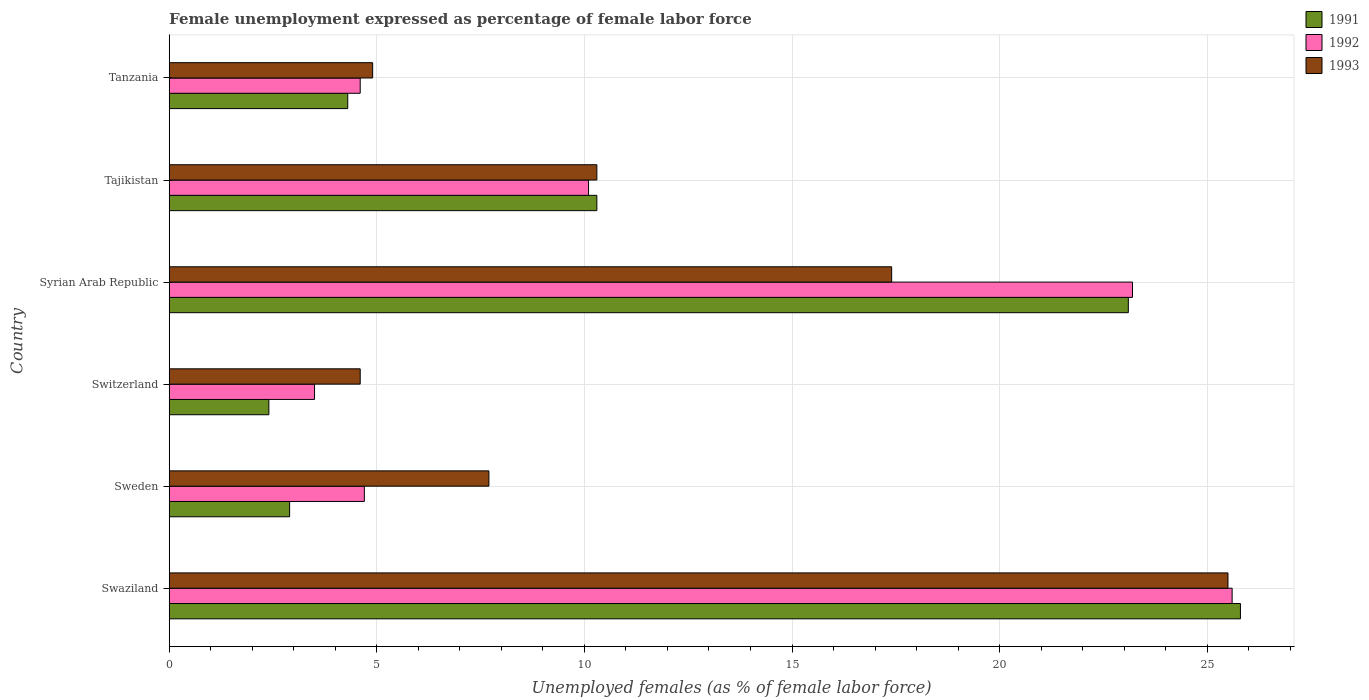Are the number of bars per tick equal to the number of legend labels?
Ensure brevity in your answer.  Yes. Are the number of bars on each tick of the Y-axis equal?
Your answer should be very brief. Yes. How many bars are there on the 6th tick from the bottom?
Keep it short and to the point. 3. What is the label of the 2nd group of bars from the top?
Provide a short and direct response. Tajikistan. In how many cases, is the number of bars for a given country not equal to the number of legend labels?
Give a very brief answer. 0. What is the unemployment in females in in 1991 in Tajikistan?
Offer a terse response. 10.3. In which country was the unemployment in females in in 1991 maximum?
Offer a very short reply. Swaziland. In which country was the unemployment in females in in 1993 minimum?
Offer a very short reply. Switzerland. What is the total unemployment in females in in 1993 in the graph?
Ensure brevity in your answer.  70.4. What is the difference between the unemployment in females in in 1993 in Syrian Arab Republic and that in Tajikistan?
Offer a terse response. 7.1. What is the difference between the unemployment in females in in 1992 in Syrian Arab Republic and the unemployment in females in in 1993 in Sweden?
Offer a terse response. 15.5. What is the average unemployment in females in in 1993 per country?
Your answer should be compact. 11.73. What is the difference between the unemployment in females in in 1991 and unemployment in females in in 1992 in Switzerland?
Ensure brevity in your answer.  -1.1. In how many countries, is the unemployment in females in in 1992 greater than 26 %?
Ensure brevity in your answer.  0. What is the ratio of the unemployment in females in in 1992 in Syrian Arab Republic to that in Tanzania?
Ensure brevity in your answer.  5.04. Is the difference between the unemployment in females in in 1991 in Swaziland and Tajikistan greater than the difference between the unemployment in females in in 1992 in Swaziland and Tajikistan?
Offer a terse response. No. What is the difference between the highest and the second highest unemployment in females in in 1992?
Your answer should be compact. 2.4. What is the difference between the highest and the lowest unemployment in females in in 1991?
Your answer should be compact. 23.4. Is the sum of the unemployment in females in in 1992 in Sweden and Syrian Arab Republic greater than the maximum unemployment in females in in 1991 across all countries?
Make the answer very short. Yes. What does the 1st bar from the bottom in Swaziland represents?
Your response must be concise. 1991. How many bars are there?
Make the answer very short. 18. Are all the bars in the graph horizontal?
Provide a succinct answer. Yes. How many countries are there in the graph?
Ensure brevity in your answer.  6. Are the values on the major ticks of X-axis written in scientific E-notation?
Your answer should be very brief. No. Does the graph contain grids?
Offer a very short reply. Yes. How many legend labels are there?
Provide a succinct answer. 3. What is the title of the graph?
Your answer should be compact. Female unemployment expressed as percentage of female labor force. What is the label or title of the X-axis?
Your answer should be very brief. Unemployed females (as % of female labor force). What is the label or title of the Y-axis?
Offer a terse response. Country. What is the Unemployed females (as % of female labor force) of 1991 in Swaziland?
Give a very brief answer. 25.8. What is the Unemployed females (as % of female labor force) of 1992 in Swaziland?
Ensure brevity in your answer.  25.6. What is the Unemployed females (as % of female labor force) of 1991 in Sweden?
Offer a very short reply. 2.9. What is the Unemployed females (as % of female labor force) in 1992 in Sweden?
Give a very brief answer. 4.7. What is the Unemployed females (as % of female labor force) of 1993 in Sweden?
Give a very brief answer. 7.7. What is the Unemployed females (as % of female labor force) in 1991 in Switzerland?
Make the answer very short. 2.4. What is the Unemployed females (as % of female labor force) of 1992 in Switzerland?
Make the answer very short. 3.5. What is the Unemployed females (as % of female labor force) of 1993 in Switzerland?
Your response must be concise. 4.6. What is the Unemployed females (as % of female labor force) of 1991 in Syrian Arab Republic?
Make the answer very short. 23.1. What is the Unemployed females (as % of female labor force) in 1992 in Syrian Arab Republic?
Give a very brief answer. 23.2. What is the Unemployed females (as % of female labor force) of 1993 in Syrian Arab Republic?
Provide a short and direct response. 17.4. What is the Unemployed females (as % of female labor force) in 1991 in Tajikistan?
Provide a succinct answer. 10.3. What is the Unemployed females (as % of female labor force) of 1992 in Tajikistan?
Your answer should be compact. 10.1. What is the Unemployed females (as % of female labor force) of 1993 in Tajikistan?
Your answer should be compact. 10.3. What is the Unemployed females (as % of female labor force) in 1991 in Tanzania?
Make the answer very short. 4.3. What is the Unemployed females (as % of female labor force) in 1992 in Tanzania?
Your response must be concise. 4.6. What is the Unemployed females (as % of female labor force) of 1993 in Tanzania?
Your answer should be very brief. 4.9. Across all countries, what is the maximum Unemployed females (as % of female labor force) of 1991?
Your answer should be very brief. 25.8. Across all countries, what is the maximum Unemployed females (as % of female labor force) in 1992?
Provide a short and direct response. 25.6. Across all countries, what is the minimum Unemployed females (as % of female labor force) in 1991?
Your response must be concise. 2.4. Across all countries, what is the minimum Unemployed females (as % of female labor force) of 1992?
Your answer should be compact. 3.5. Across all countries, what is the minimum Unemployed females (as % of female labor force) of 1993?
Ensure brevity in your answer.  4.6. What is the total Unemployed females (as % of female labor force) of 1991 in the graph?
Your answer should be very brief. 68.8. What is the total Unemployed females (as % of female labor force) in 1992 in the graph?
Your answer should be compact. 71.7. What is the total Unemployed females (as % of female labor force) of 1993 in the graph?
Offer a very short reply. 70.4. What is the difference between the Unemployed females (as % of female labor force) in 1991 in Swaziland and that in Sweden?
Your answer should be very brief. 22.9. What is the difference between the Unemployed females (as % of female labor force) of 1992 in Swaziland and that in Sweden?
Make the answer very short. 20.9. What is the difference between the Unemployed females (as % of female labor force) in 1993 in Swaziland and that in Sweden?
Ensure brevity in your answer.  17.8. What is the difference between the Unemployed females (as % of female labor force) of 1991 in Swaziland and that in Switzerland?
Provide a succinct answer. 23.4. What is the difference between the Unemployed females (as % of female labor force) of 1992 in Swaziland and that in Switzerland?
Give a very brief answer. 22.1. What is the difference between the Unemployed females (as % of female labor force) of 1993 in Swaziland and that in Switzerland?
Make the answer very short. 20.9. What is the difference between the Unemployed females (as % of female labor force) of 1992 in Swaziland and that in Syrian Arab Republic?
Your answer should be compact. 2.4. What is the difference between the Unemployed females (as % of female labor force) in 1993 in Swaziland and that in Syrian Arab Republic?
Ensure brevity in your answer.  8.1. What is the difference between the Unemployed females (as % of female labor force) in 1991 in Swaziland and that in Tajikistan?
Provide a short and direct response. 15.5. What is the difference between the Unemployed females (as % of female labor force) in 1992 in Swaziland and that in Tajikistan?
Provide a succinct answer. 15.5. What is the difference between the Unemployed females (as % of female labor force) in 1991 in Swaziland and that in Tanzania?
Your answer should be compact. 21.5. What is the difference between the Unemployed females (as % of female labor force) in 1993 in Swaziland and that in Tanzania?
Offer a very short reply. 20.6. What is the difference between the Unemployed females (as % of female labor force) in 1993 in Sweden and that in Switzerland?
Offer a very short reply. 3.1. What is the difference between the Unemployed females (as % of female labor force) in 1991 in Sweden and that in Syrian Arab Republic?
Ensure brevity in your answer.  -20.2. What is the difference between the Unemployed females (as % of female labor force) of 1992 in Sweden and that in Syrian Arab Republic?
Your response must be concise. -18.5. What is the difference between the Unemployed females (as % of female labor force) of 1993 in Sweden and that in Syrian Arab Republic?
Your answer should be compact. -9.7. What is the difference between the Unemployed females (as % of female labor force) of 1993 in Sweden and that in Tajikistan?
Provide a succinct answer. -2.6. What is the difference between the Unemployed females (as % of female labor force) of 1991 in Sweden and that in Tanzania?
Ensure brevity in your answer.  -1.4. What is the difference between the Unemployed females (as % of female labor force) in 1993 in Sweden and that in Tanzania?
Keep it short and to the point. 2.8. What is the difference between the Unemployed females (as % of female labor force) in 1991 in Switzerland and that in Syrian Arab Republic?
Your response must be concise. -20.7. What is the difference between the Unemployed females (as % of female labor force) in 1992 in Switzerland and that in Syrian Arab Republic?
Offer a terse response. -19.7. What is the difference between the Unemployed females (as % of female labor force) of 1992 in Switzerland and that in Tajikistan?
Your response must be concise. -6.6. What is the difference between the Unemployed females (as % of female labor force) of 1992 in Switzerland and that in Tanzania?
Provide a succinct answer. -1.1. What is the difference between the Unemployed females (as % of female labor force) in 1993 in Switzerland and that in Tanzania?
Provide a succinct answer. -0.3. What is the difference between the Unemployed females (as % of female labor force) of 1991 in Syrian Arab Republic and that in Tajikistan?
Ensure brevity in your answer.  12.8. What is the difference between the Unemployed females (as % of female labor force) in 1992 in Syrian Arab Republic and that in Tanzania?
Offer a very short reply. 18.6. What is the difference between the Unemployed females (as % of female labor force) of 1993 in Syrian Arab Republic and that in Tanzania?
Provide a short and direct response. 12.5. What is the difference between the Unemployed females (as % of female labor force) of 1991 in Tajikistan and that in Tanzania?
Make the answer very short. 6. What is the difference between the Unemployed females (as % of female labor force) of 1992 in Tajikistan and that in Tanzania?
Offer a very short reply. 5.5. What is the difference between the Unemployed females (as % of female labor force) in 1993 in Tajikistan and that in Tanzania?
Make the answer very short. 5.4. What is the difference between the Unemployed females (as % of female labor force) in 1991 in Swaziland and the Unemployed females (as % of female labor force) in 1992 in Sweden?
Give a very brief answer. 21.1. What is the difference between the Unemployed females (as % of female labor force) in 1991 in Swaziland and the Unemployed females (as % of female labor force) in 1992 in Switzerland?
Provide a succinct answer. 22.3. What is the difference between the Unemployed females (as % of female labor force) of 1991 in Swaziland and the Unemployed females (as % of female labor force) of 1993 in Switzerland?
Make the answer very short. 21.2. What is the difference between the Unemployed females (as % of female labor force) of 1992 in Swaziland and the Unemployed females (as % of female labor force) of 1993 in Switzerland?
Your answer should be compact. 21. What is the difference between the Unemployed females (as % of female labor force) of 1991 in Swaziland and the Unemployed females (as % of female labor force) of 1992 in Syrian Arab Republic?
Provide a short and direct response. 2.6. What is the difference between the Unemployed females (as % of female labor force) of 1991 in Swaziland and the Unemployed females (as % of female labor force) of 1992 in Tajikistan?
Keep it short and to the point. 15.7. What is the difference between the Unemployed females (as % of female labor force) in 1991 in Swaziland and the Unemployed females (as % of female labor force) in 1992 in Tanzania?
Ensure brevity in your answer.  21.2. What is the difference between the Unemployed females (as % of female labor force) of 1991 in Swaziland and the Unemployed females (as % of female labor force) of 1993 in Tanzania?
Provide a short and direct response. 20.9. What is the difference between the Unemployed females (as % of female labor force) of 1992 in Swaziland and the Unemployed females (as % of female labor force) of 1993 in Tanzania?
Make the answer very short. 20.7. What is the difference between the Unemployed females (as % of female labor force) of 1991 in Sweden and the Unemployed females (as % of female labor force) of 1992 in Switzerland?
Your answer should be compact. -0.6. What is the difference between the Unemployed females (as % of female labor force) in 1991 in Sweden and the Unemployed females (as % of female labor force) in 1993 in Switzerland?
Keep it short and to the point. -1.7. What is the difference between the Unemployed females (as % of female labor force) in 1991 in Sweden and the Unemployed females (as % of female labor force) in 1992 in Syrian Arab Republic?
Keep it short and to the point. -20.3. What is the difference between the Unemployed females (as % of female labor force) of 1991 in Sweden and the Unemployed females (as % of female labor force) of 1993 in Syrian Arab Republic?
Offer a very short reply. -14.5. What is the difference between the Unemployed females (as % of female labor force) of 1992 in Sweden and the Unemployed females (as % of female labor force) of 1993 in Syrian Arab Republic?
Make the answer very short. -12.7. What is the difference between the Unemployed females (as % of female labor force) of 1991 in Sweden and the Unemployed females (as % of female labor force) of 1992 in Tajikistan?
Your answer should be compact. -7.2. What is the difference between the Unemployed females (as % of female labor force) in 1992 in Sweden and the Unemployed females (as % of female labor force) in 1993 in Tajikistan?
Keep it short and to the point. -5.6. What is the difference between the Unemployed females (as % of female labor force) in 1991 in Sweden and the Unemployed females (as % of female labor force) in 1993 in Tanzania?
Make the answer very short. -2. What is the difference between the Unemployed females (as % of female labor force) in 1992 in Sweden and the Unemployed females (as % of female labor force) in 1993 in Tanzania?
Give a very brief answer. -0.2. What is the difference between the Unemployed females (as % of female labor force) of 1991 in Switzerland and the Unemployed females (as % of female labor force) of 1992 in Syrian Arab Republic?
Your response must be concise. -20.8. What is the difference between the Unemployed females (as % of female labor force) of 1992 in Switzerland and the Unemployed females (as % of female labor force) of 1993 in Syrian Arab Republic?
Ensure brevity in your answer.  -13.9. What is the difference between the Unemployed females (as % of female labor force) of 1991 in Switzerland and the Unemployed females (as % of female labor force) of 1992 in Tajikistan?
Offer a very short reply. -7.7. What is the difference between the Unemployed females (as % of female labor force) of 1991 in Switzerland and the Unemployed females (as % of female labor force) of 1992 in Tanzania?
Ensure brevity in your answer.  -2.2. What is the difference between the Unemployed females (as % of female labor force) of 1991 in Switzerland and the Unemployed females (as % of female labor force) of 1993 in Tanzania?
Your answer should be very brief. -2.5. What is the difference between the Unemployed females (as % of female labor force) in 1992 in Switzerland and the Unemployed females (as % of female labor force) in 1993 in Tanzania?
Your answer should be very brief. -1.4. What is the difference between the Unemployed females (as % of female labor force) of 1991 in Syrian Arab Republic and the Unemployed females (as % of female labor force) of 1992 in Tajikistan?
Offer a very short reply. 13. What is the difference between the Unemployed females (as % of female labor force) in 1992 in Syrian Arab Republic and the Unemployed females (as % of female labor force) in 1993 in Tajikistan?
Your answer should be compact. 12.9. What is the difference between the Unemployed females (as % of female labor force) in 1992 in Syrian Arab Republic and the Unemployed females (as % of female labor force) in 1993 in Tanzania?
Provide a succinct answer. 18.3. What is the difference between the Unemployed females (as % of female labor force) of 1991 in Tajikistan and the Unemployed females (as % of female labor force) of 1992 in Tanzania?
Provide a short and direct response. 5.7. What is the difference between the Unemployed females (as % of female labor force) of 1991 in Tajikistan and the Unemployed females (as % of female labor force) of 1993 in Tanzania?
Your answer should be compact. 5.4. What is the difference between the Unemployed females (as % of female labor force) of 1992 in Tajikistan and the Unemployed females (as % of female labor force) of 1993 in Tanzania?
Give a very brief answer. 5.2. What is the average Unemployed females (as % of female labor force) of 1991 per country?
Keep it short and to the point. 11.47. What is the average Unemployed females (as % of female labor force) of 1992 per country?
Make the answer very short. 11.95. What is the average Unemployed females (as % of female labor force) of 1993 per country?
Give a very brief answer. 11.73. What is the difference between the Unemployed females (as % of female labor force) in 1991 and Unemployed females (as % of female labor force) in 1992 in Swaziland?
Your answer should be compact. 0.2. What is the difference between the Unemployed females (as % of female labor force) in 1991 and Unemployed females (as % of female labor force) in 1992 in Sweden?
Your answer should be very brief. -1.8. What is the difference between the Unemployed females (as % of female labor force) in 1991 and Unemployed females (as % of female labor force) in 1993 in Sweden?
Give a very brief answer. -4.8. What is the difference between the Unemployed females (as % of female labor force) in 1991 and Unemployed females (as % of female labor force) in 1992 in Switzerland?
Provide a succinct answer. -1.1. What is the difference between the Unemployed females (as % of female labor force) in 1991 and Unemployed females (as % of female labor force) in 1993 in Switzerland?
Provide a succinct answer. -2.2. What is the difference between the Unemployed females (as % of female labor force) in 1992 and Unemployed females (as % of female labor force) in 1993 in Switzerland?
Offer a very short reply. -1.1. What is the difference between the Unemployed females (as % of female labor force) in 1992 and Unemployed females (as % of female labor force) in 1993 in Syrian Arab Republic?
Provide a short and direct response. 5.8. What is the difference between the Unemployed females (as % of female labor force) of 1992 and Unemployed females (as % of female labor force) of 1993 in Tajikistan?
Make the answer very short. -0.2. What is the ratio of the Unemployed females (as % of female labor force) of 1991 in Swaziland to that in Sweden?
Offer a very short reply. 8.9. What is the ratio of the Unemployed females (as % of female labor force) of 1992 in Swaziland to that in Sweden?
Offer a terse response. 5.45. What is the ratio of the Unemployed females (as % of female labor force) in 1993 in Swaziland to that in Sweden?
Offer a very short reply. 3.31. What is the ratio of the Unemployed females (as % of female labor force) of 1991 in Swaziland to that in Switzerland?
Give a very brief answer. 10.75. What is the ratio of the Unemployed females (as % of female labor force) in 1992 in Swaziland to that in Switzerland?
Provide a succinct answer. 7.31. What is the ratio of the Unemployed females (as % of female labor force) in 1993 in Swaziland to that in Switzerland?
Offer a very short reply. 5.54. What is the ratio of the Unemployed females (as % of female labor force) of 1991 in Swaziland to that in Syrian Arab Republic?
Offer a very short reply. 1.12. What is the ratio of the Unemployed females (as % of female labor force) of 1992 in Swaziland to that in Syrian Arab Republic?
Your answer should be very brief. 1.1. What is the ratio of the Unemployed females (as % of female labor force) in 1993 in Swaziland to that in Syrian Arab Republic?
Make the answer very short. 1.47. What is the ratio of the Unemployed females (as % of female labor force) of 1991 in Swaziland to that in Tajikistan?
Provide a succinct answer. 2.5. What is the ratio of the Unemployed females (as % of female labor force) of 1992 in Swaziland to that in Tajikistan?
Your response must be concise. 2.53. What is the ratio of the Unemployed females (as % of female labor force) in 1993 in Swaziland to that in Tajikistan?
Your answer should be compact. 2.48. What is the ratio of the Unemployed females (as % of female labor force) of 1992 in Swaziland to that in Tanzania?
Make the answer very short. 5.57. What is the ratio of the Unemployed females (as % of female labor force) in 1993 in Swaziland to that in Tanzania?
Give a very brief answer. 5.2. What is the ratio of the Unemployed females (as % of female labor force) of 1991 in Sweden to that in Switzerland?
Your answer should be compact. 1.21. What is the ratio of the Unemployed females (as % of female labor force) of 1992 in Sweden to that in Switzerland?
Offer a terse response. 1.34. What is the ratio of the Unemployed females (as % of female labor force) of 1993 in Sweden to that in Switzerland?
Offer a terse response. 1.67. What is the ratio of the Unemployed females (as % of female labor force) of 1991 in Sweden to that in Syrian Arab Republic?
Ensure brevity in your answer.  0.13. What is the ratio of the Unemployed females (as % of female labor force) of 1992 in Sweden to that in Syrian Arab Republic?
Offer a terse response. 0.2. What is the ratio of the Unemployed females (as % of female labor force) in 1993 in Sweden to that in Syrian Arab Republic?
Your answer should be very brief. 0.44. What is the ratio of the Unemployed females (as % of female labor force) in 1991 in Sweden to that in Tajikistan?
Provide a succinct answer. 0.28. What is the ratio of the Unemployed females (as % of female labor force) in 1992 in Sweden to that in Tajikistan?
Provide a short and direct response. 0.47. What is the ratio of the Unemployed females (as % of female labor force) of 1993 in Sweden to that in Tajikistan?
Ensure brevity in your answer.  0.75. What is the ratio of the Unemployed females (as % of female labor force) in 1991 in Sweden to that in Tanzania?
Make the answer very short. 0.67. What is the ratio of the Unemployed females (as % of female labor force) in 1992 in Sweden to that in Tanzania?
Offer a terse response. 1.02. What is the ratio of the Unemployed females (as % of female labor force) of 1993 in Sweden to that in Tanzania?
Give a very brief answer. 1.57. What is the ratio of the Unemployed females (as % of female labor force) in 1991 in Switzerland to that in Syrian Arab Republic?
Your answer should be very brief. 0.1. What is the ratio of the Unemployed females (as % of female labor force) in 1992 in Switzerland to that in Syrian Arab Republic?
Make the answer very short. 0.15. What is the ratio of the Unemployed females (as % of female labor force) of 1993 in Switzerland to that in Syrian Arab Republic?
Your answer should be compact. 0.26. What is the ratio of the Unemployed females (as % of female labor force) of 1991 in Switzerland to that in Tajikistan?
Give a very brief answer. 0.23. What is the ratio of the Unemployed females (as % of female labor force) of 1992 in Switzerland to that in Tajikistan?
Your response must be concise. 0.35. What is the ratio of the Unemployed females (as % of female labor force) in 1993 in Switzerland to that in Tajikistan?
Your answer should be compact. 0.45. What is the ratio of the Unemployed females (as % of female labor force) of 1991 in Switzerland to that in Tanzania?
Ensure brevity in your answer.  0.56. What is the ratio of the Unemployed females (as % of female labor force) in 1992 in Switzerland to that in Tanzania?
Make the answer very short. 0.76. What is the ratio of the Unemployed females (as % of female labor force) of 1993 in Switzerland to that in Tanzania?
Provide a succinct answer. 0.94. What is the ratio of the Unemployed females (as % of female labor force) of 1991 in Syrian Arab Republic to that in Tajikistan?
Give a very brief answer. 2.24. What is the ratio of the Unemployed females (as % of female labor force) in 1992 in Syrian Arab Republic to that in Tajikistan?
Offer a very short reply. 2.3. What is the ratio of the Unemployed females (as % of female labor force) in 1993 in Syrian Arab Republic to that in Tajikistan?
Offer a very short reply. 1.69. What is the ratio of the Unemployed females (as % of female labor force) of 1991 in Syrian Arab Republic to that in Tanzania?
Your answer should be compact. 5.37. What is the ratio of the Unemployed females (as % of female labor force) in 1992 in Syrian Arab Republic to that in Tanzania?
Provide a succinct answer. 5.04. What is the ratio of the Unemployed females (as % of female labor force) of 1993 in Syrian Arab Republic to that in Tanzania?
Give a very brief answer. 3.55. What is the ratio of the Unemployed females (as % of female labor force) of 1991 in Tajikistan to that in Tanzania?
Provide a short and direct response. 2.4. What is the ratio of the Unemployed females (as % of female labor force) of 1992 in Tajikistan to that in Tanzania?
Offer a very short reply. 2.2. What is the ratio of the Unemployed females (as % of female labor force) of 1993 in Tajikistan to that in Tanzania?
Offer a terse response. 2.1. What is the difference between the highest and the second highest Unemployed females (as % of female labor force) of 1992?
Keep it short and to the point. 2.4. What is the difference between the highest and the second highest Unemployed females (as % of female labor force) in 1993?
Make the answer very short. 8.1. What is the difference between the highest and the lowest Unemployed females (as % of female labor force) of 1991?
Ensure brevity in your answer.  23.4. What is the difference between the highest and the lowest Unemployed females (as % of female labor force) of 1992?
Offer a terse response. 22.1. What is the difference between the highest and the lowest Unemployed females (as % of female labor force) of 1993?
Your answer should be very brief. 20.9. 